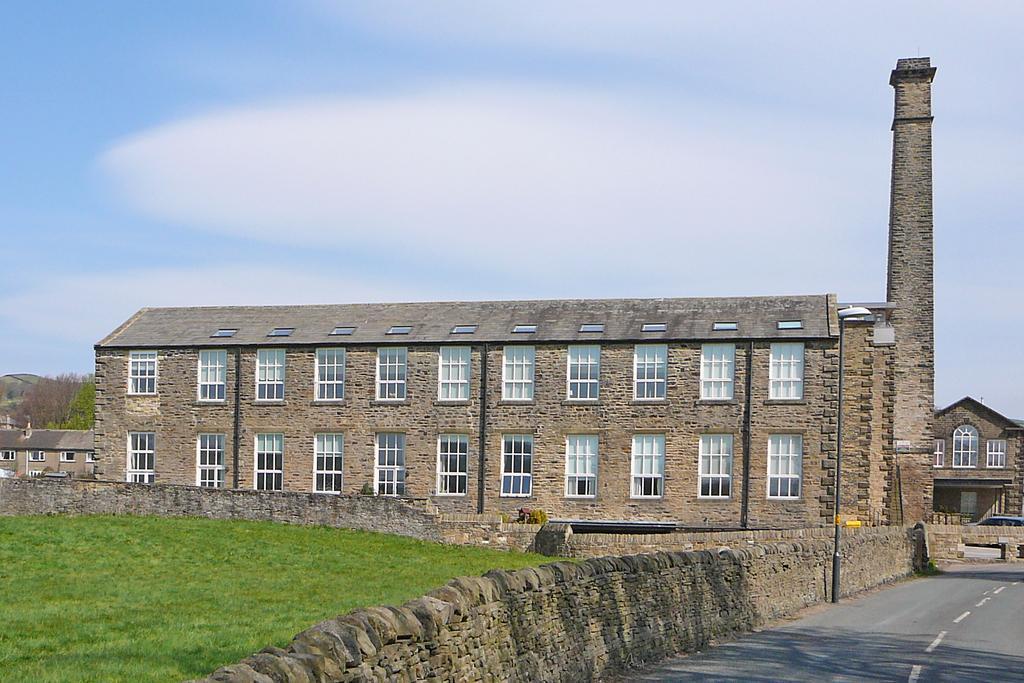Could you give a brief overview of what you see in this image? In this image there is the sky truncated towards the top of the image, there are clouds in the sky, there are houses, there is a house truncated towards the right of the image, there is a house truncated towards the left of the image, there are windows, there is a tower, there are trees, there is an object truncated towards the left of the image, there is grass truncated towards the bottom of the image, there is wall truncated towards the left of the image, there is a pole, there is a street light, there is a vehicle, there is road truncated towards the right of the image. 